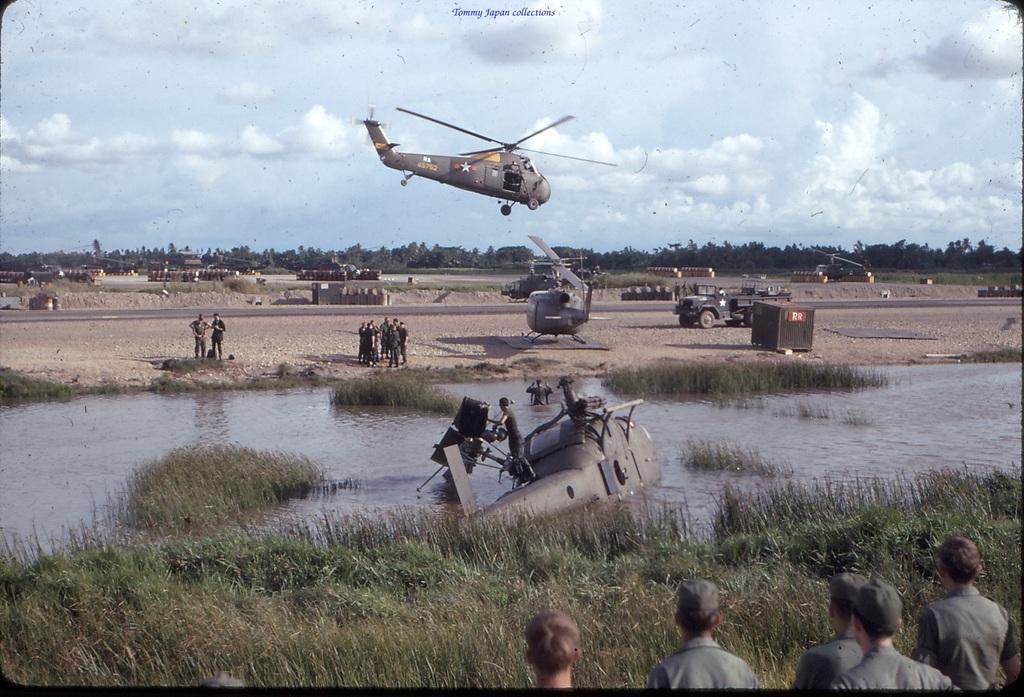Please provide a concise description of this image. There is a helicopter in the water. Also there are many people. On the ground there is grass. One helicopter is flying. In the back there is a vehicle. In the background there are trees and sky with clouds. 